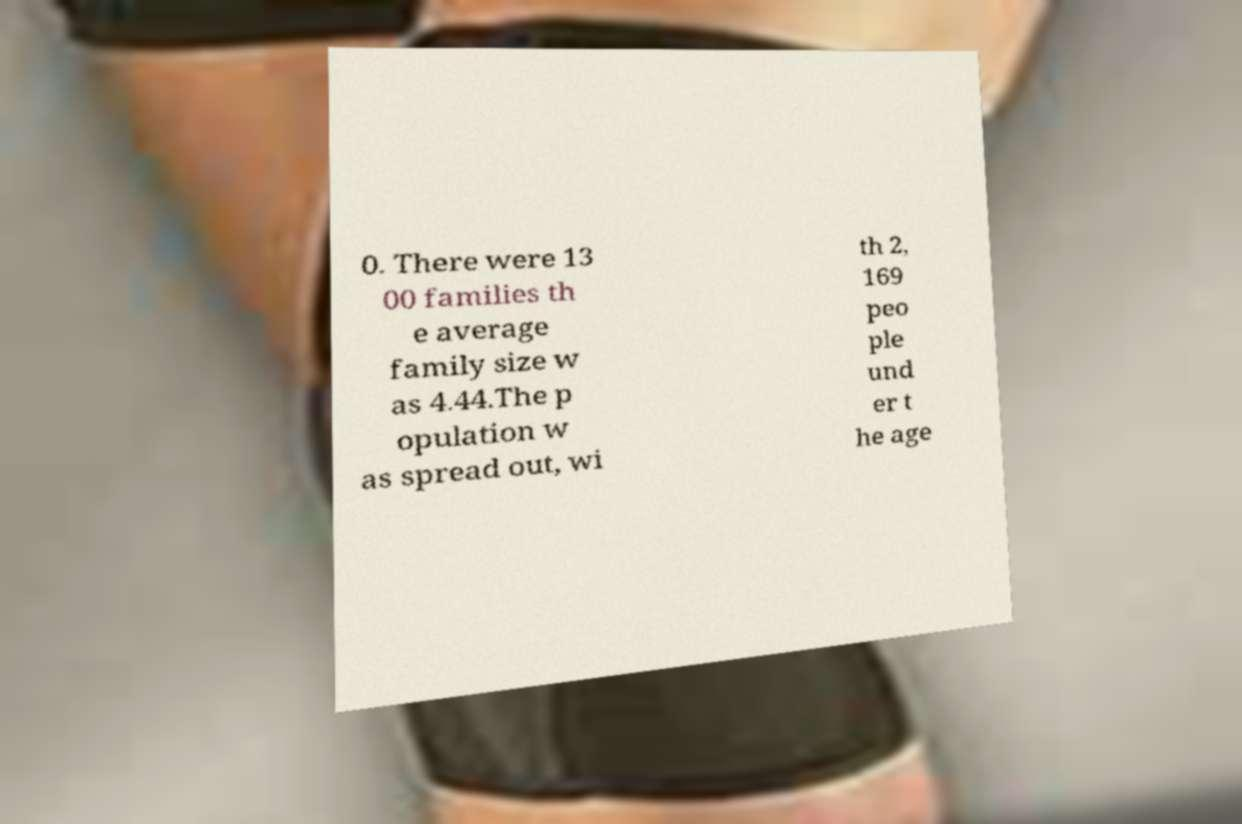Can you read and provide the text displayed in the image?This photo seems to have some interesting text. Can you extract and type it out for me? 0. There were 13 00 families th e average family size w as 4.44.The p opulation w as spread out, wi th 2, 169 peo ple und er t he age 